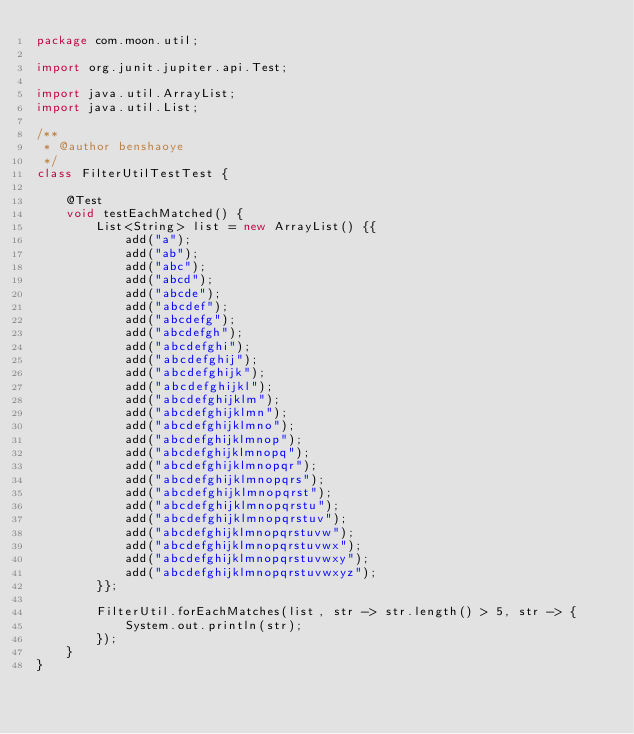<code> <loc_0><loc_0><loc_500><loc_500><_Java_>package com.moon.util;

import org.junit.jupiter.api.Test;

import java.util.ArrayList;
import java.util.List;

/**
 * @author benshaoye
 */
class FilterUtilTestTest {

    @Test
    void testEachMatched() {
        List<String> list = new ArrayList() {{
            add("a");
            add("ab");
            add("abc");
            add("abcd");
            add("abcde");
            add("abcdef");
            add("abcdefg");
            add("abcdefgh");
            add("abcdefghi");
            add("abcdefghij");
            add("abcdefghijk");
            add("abcdefghijkl");
            add("abcdefghijklm");
            add("abcdefghijklmn");
            add("abcdefghijklmno");
            add("abcdefghijklmnop");
            add("abcdefghijklmnopq");
            add("abcdefghijklmnopqr");
            add("abcdefghijklmnopqrs");
            add("abcdefghijklmnopqrst");
            add("abcdefghijklmnopqrstu");
            add("abcdefghijklmnopqrstuv");
            add("abcdefghijklmnopqrstuvw");
            add("abcdefghijklmnopqrstuvwx");
            add("abcdefghijklmnopqrstuvwxy");
            add("abcdefghijklmnopqrstuvwxyz");
        }};

        FilterUtil.forEachMatches(list, str -> str.length() > 5, str -> {
            System.out.println(str);
        });
    }
}</code> 